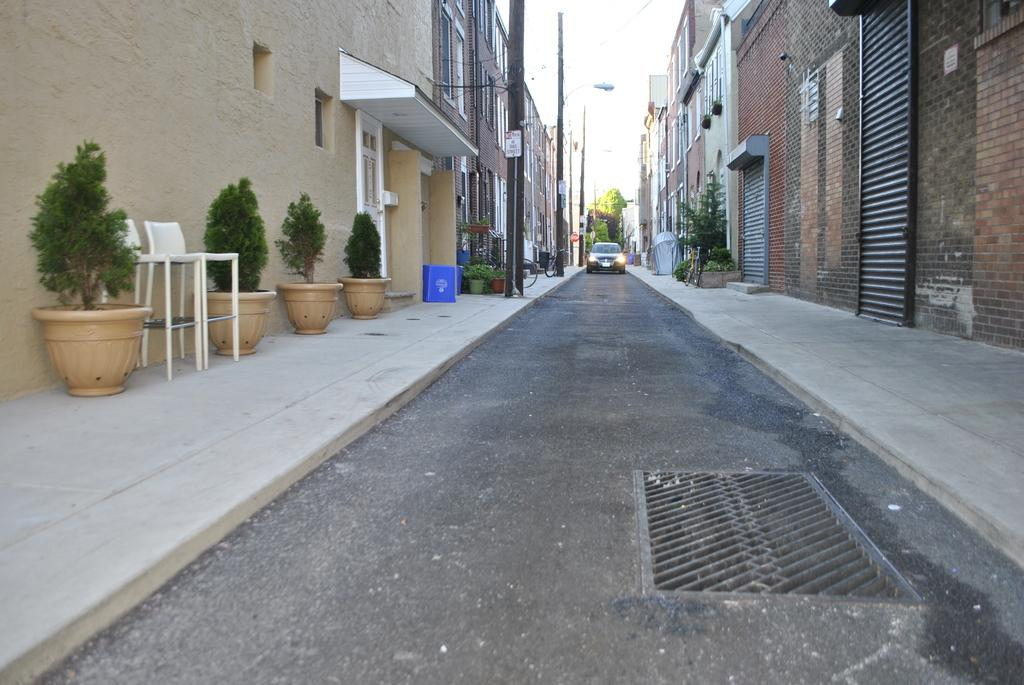What is the main feature of the image? There is a road in the image. What is happening on the road? A vehicle is present on the road. What else can be seen in the image besides the road and vehicle? There are buildings, poles, chairs, and plants in pots visible in the image. Can you see any boats navigating through the stream in the image? There is no stream or boats present in the image. What type of pies are being served on the chairs in the image? There are no pies visible in the image; only chairs and plants in pots are present. 